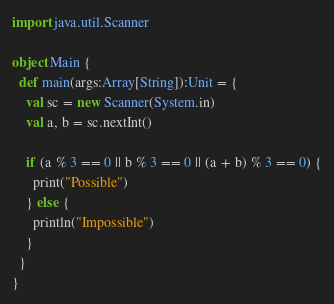Convert code to text. <code><loc_0><loc_0><loc_500><loc_500><_Scala_>import java.util.Scanner

object Main {
  def main(args:Array[String]):Unit = {
    val sc = new Scanner(System.in)
    val a, b = sc.nextInt()

    if (a % 3 == 0 || b % 3 == 0 || (a + b) % 3 == 0) {
      print("Possible")
    } else {
      println("Impossible")
    }
  }
}</code> 